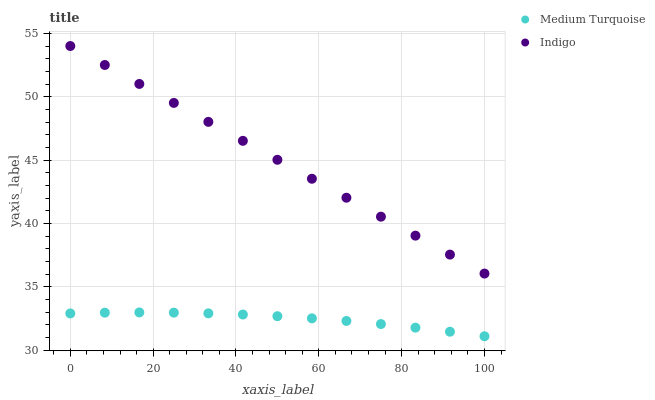Does Medium Turquoise have the minimum area under the curve?
Answer yes or no. Yes. Does Indigo have the maximum area under the curve?
Answer yes or no. Yes. Does Medium Turquoise have the maximum area under the curve?
Answer yes or no. No. Is Indigo the smoothest?
Answer yes or no. Yes. Is Medium Turquoise the roughest?
Answer yes or no. Yes. Is Medium Turquoise the smoothest?
Answer yes or no. No. Does Medium Turquoise have the lowest value?
Answer yes or no. Yes. Does Indigo have the highest value?
Answer yes or no. Yes. Does Medium Turquoise have the highest value?
Answer yes or no. No. Is Medium Turquoise less than Indigo?
Answer yes or no. Yes. Is Indigo greater than Medium Turquoise?
Answer yes or no. Yes. Does Medium Turquoise intersect Indigo?
Answer yes or no. No. 